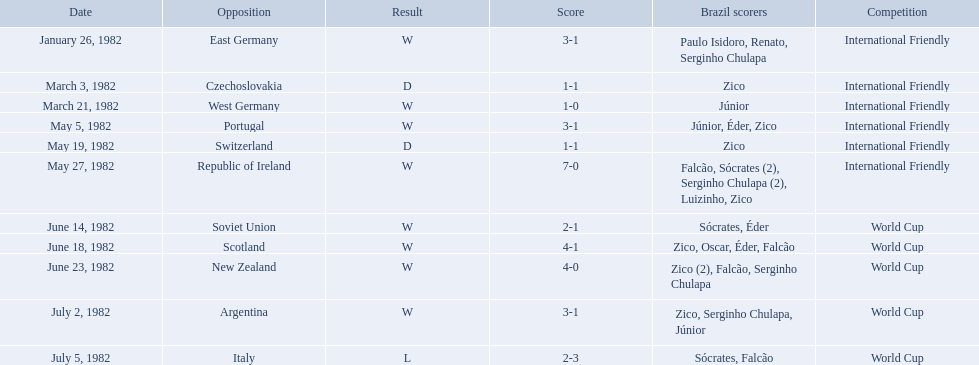What are the dates January 26, 1982, March 3, 1982, March 21, 1982, May 5, 1982, May 19, 1982, May 27, 1982, June 14, 1982, June 18, 1982, June 23, 1982, July 2, 1982, July 5, 1982. Which date is at the top? January 26, 1982. How many goals did brazil score against the soviet union? 2-1. How many goals did brazil score against portugal? 3-1. Did brazil score more goals against portugal or the soviet union? Portugal. How many objectives did brazil tally against the soviet union? 2-1. How many objectives did brazil tally against portugal? 3-1. Did brazil record more objectives against portugal or the soviet union? Portugal. In the 1982 brazilian football matches, what were the scores for each game? 3-1, 1-1, 1-0, 3-1, 1-1, 7-0, 2-1, 4-1, 4-0, 3-1, 2-3. Can you provide the scores for the games involving portugal and the soviet union? 3-1, 2-1. In which of these two games did brazil score the most goals? Portugal. How many goals were scored by brazil in their match against the soviet union? 2-1. How many goals were scored by brazil in their match against portugal? 3-1. Did brazil have a higher goal count against portugal or the soviet union? Portugal. Can you give me this table in json format? {'header': ['Date', 'Opposition', 'Result', 'Score', 'Brazil scorers', 'Competition'], 'rows': [['January 26, 1982', 'East Germany', 'W', '3-1', 'Paulo Isidoro, Renato, Serginho Chulapa', 'International Friendly'], ['March 3, 1982', 'Czechoslovakia', 'D', '1-1', 'Zico', 'International Friendly'], ['March 21, 1982', 'West Germany', 'W', '1-0', 'Júnior', 'International Friendly'], ['May 5, 1982', 'Portugal', 'W', '3-1', 'Júnior, Éder, Zico', 'International Friendly'], ['May 19, 1982', 'Switzerland', 'D', '1-1', 'Zico', 'International Friendly'], ['May 27, 1982', 'Republic of Ireland', 'W', '7-0', 'Falcão, Sócrates (2), Serginho Chulapa (2), Luizinho, Zico', 'International Friendly'], ['June 14, 1982', 'Soviet Union', 'W', '2-1', 'Sócrates, Éder', 'World Cup'], ['June 18, 1982', 'Scotland', 'W', '4-1', 'Zico, Oscar, Éder, Falcão', 'World Cup'], ['June 23, 1982', 'New Zealand', 'W', '4-0', 'Zico (2), Falcão, Serginho Chulapa', 'World Cup'], ['July 2, 1982', 'Argentina', 'W', '3-1', 'Zico, Serginho Chulapa, Júnior', 'World Cup'], ['July 5, 1982', 'Italy', 'L', '2-3', 'Sócrates, Falcão', 'World Cup']]} What was brazil's goal count in their match against the soviet union? 2-1. What was brazil's goal count in their match against portugal? 3-1. Between portugal and the soviet union, which team did brazil score more goals against? Portugal. 